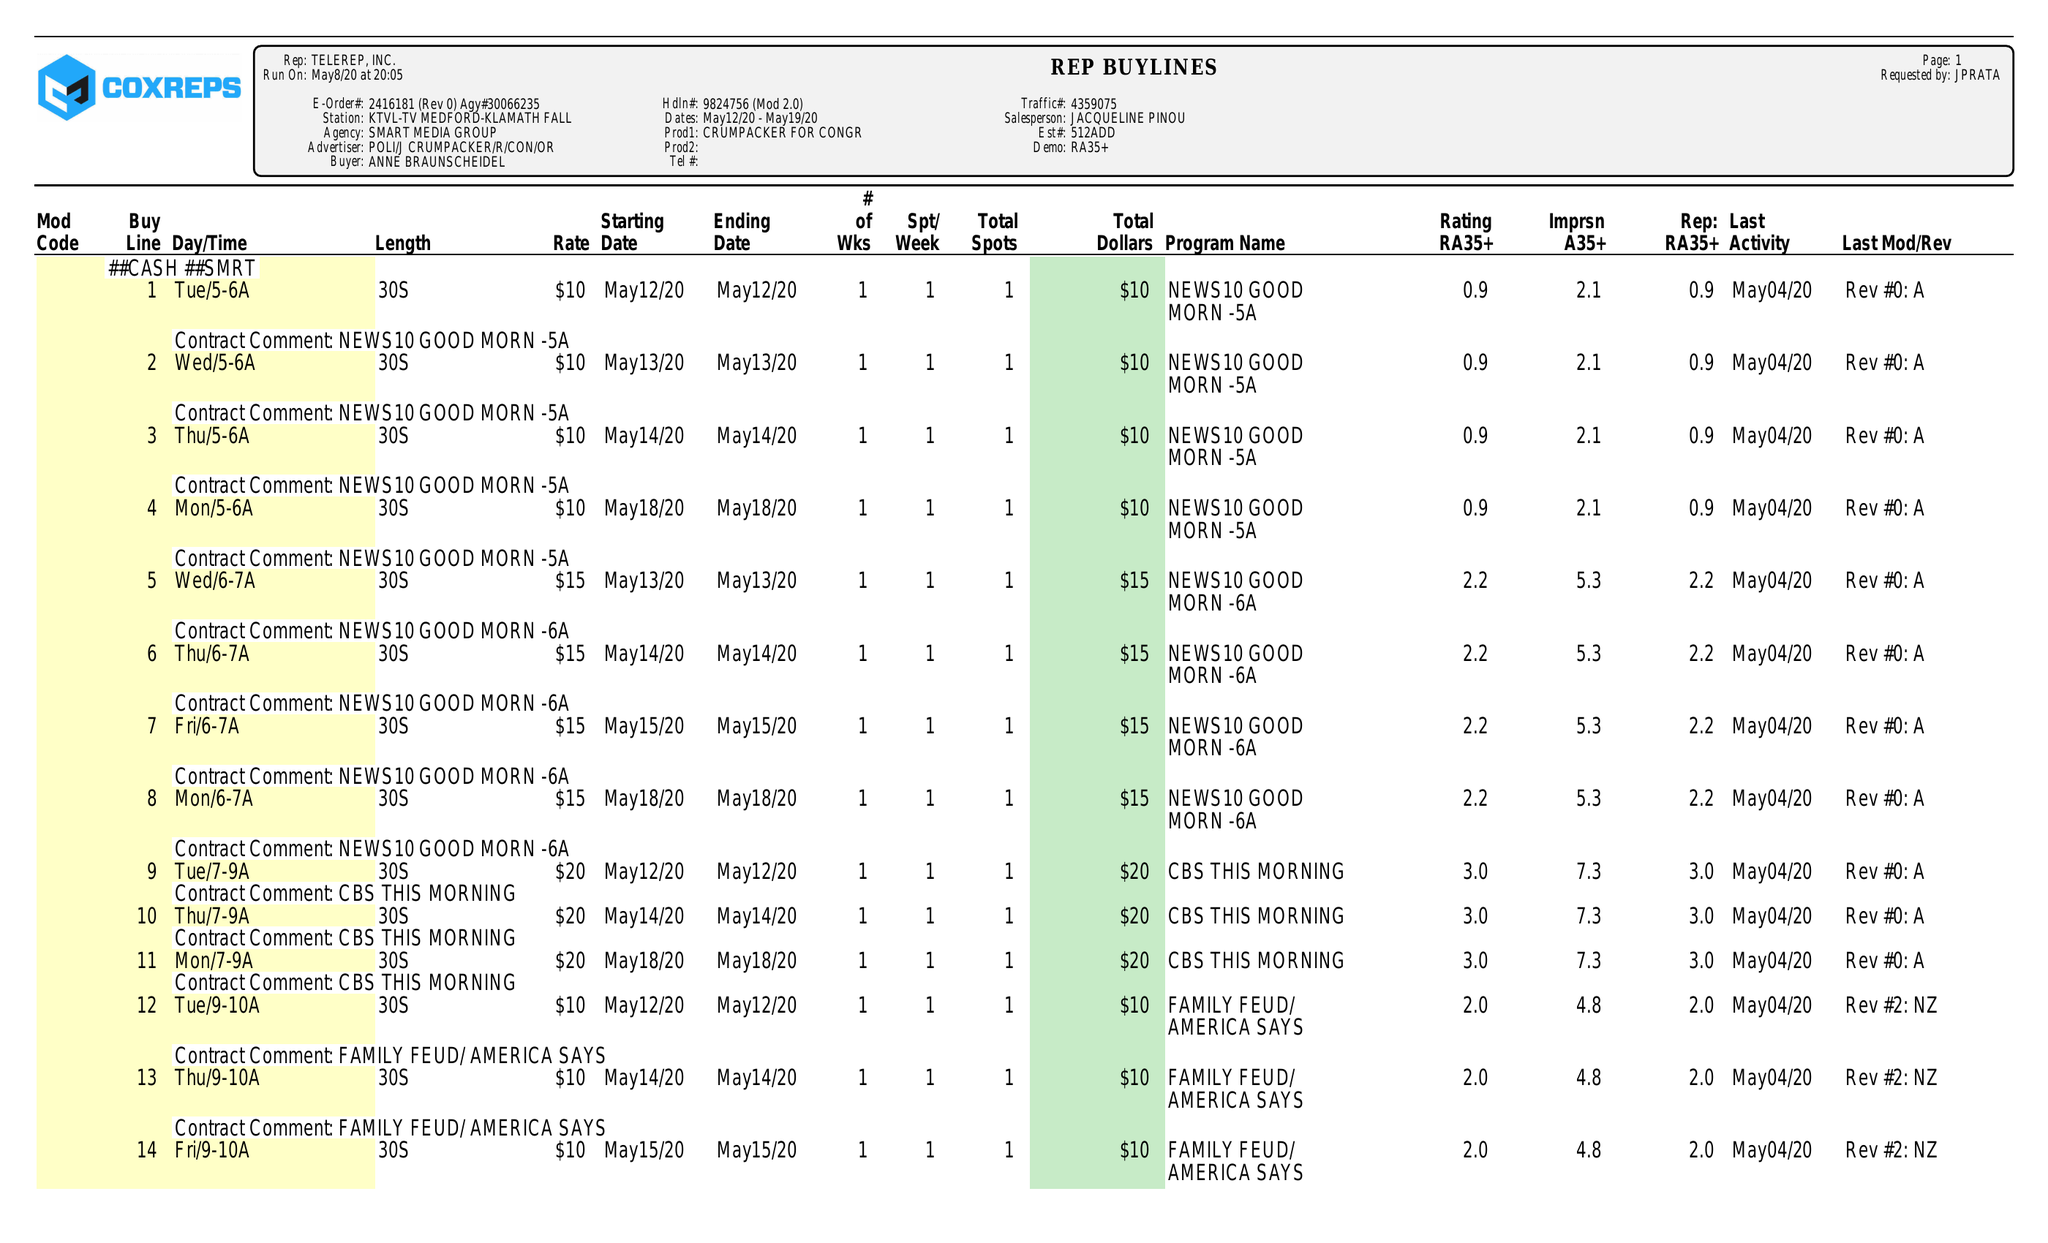What is the value for the flight_to?
Answer the question using a single word or phrase. 05/19/20 